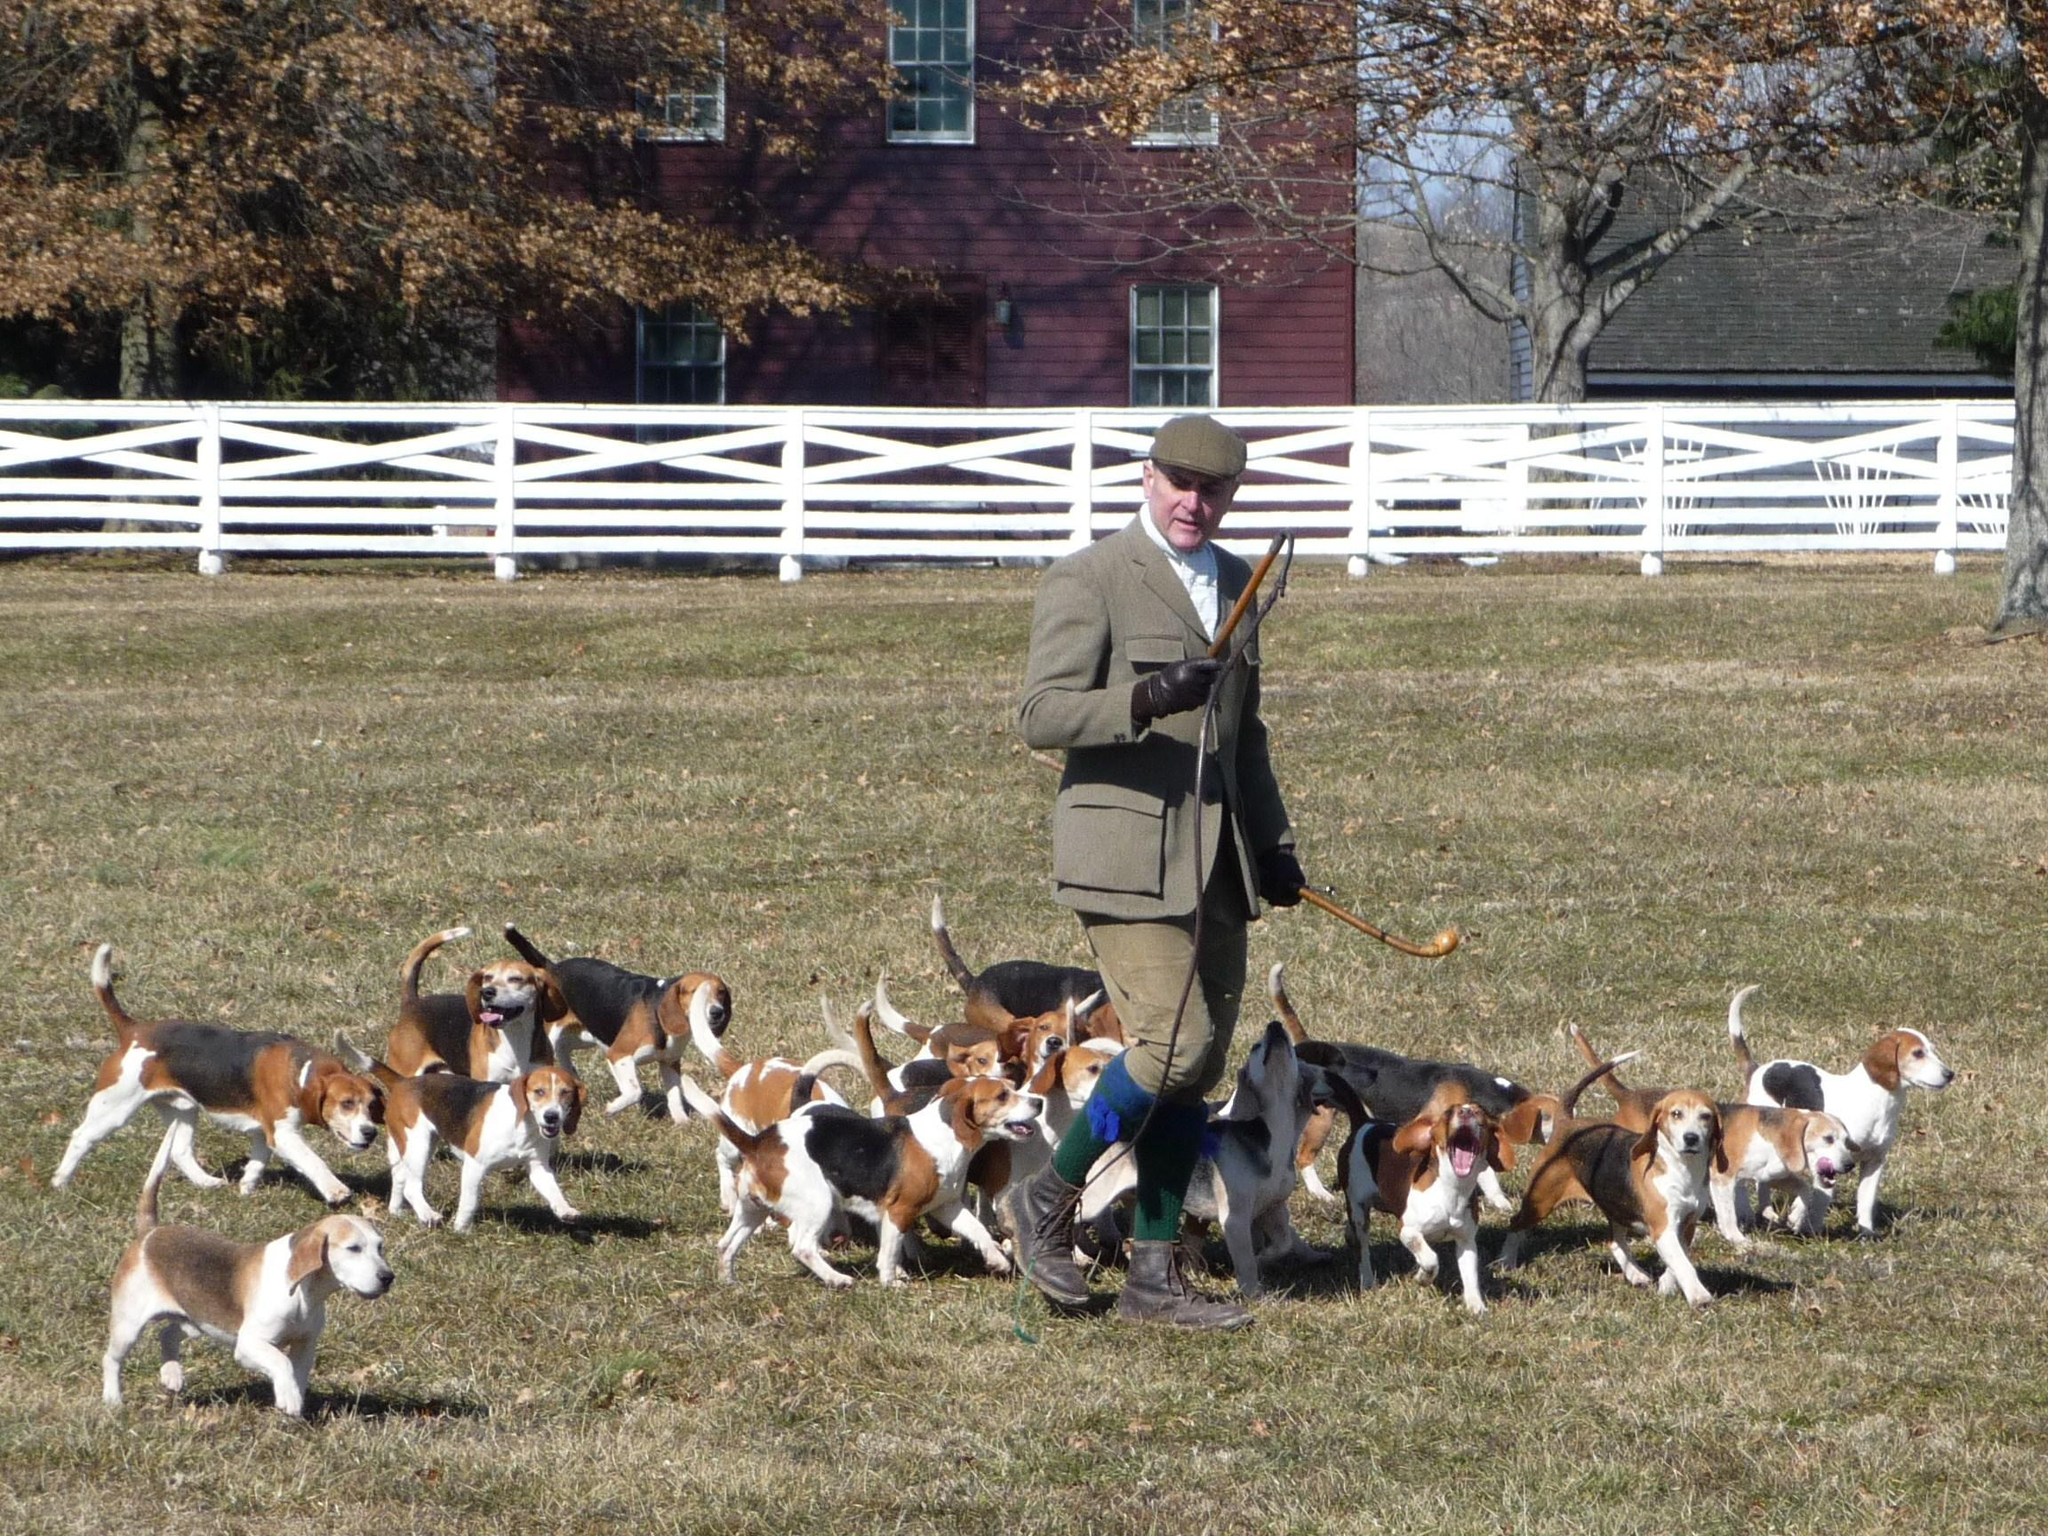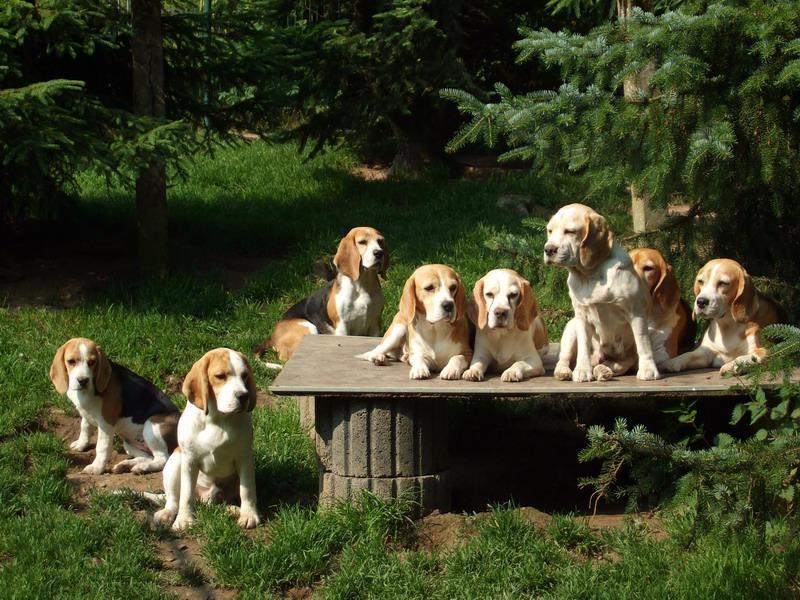The first image is the image on the left, the second image is the image on the right. Evaluate the accuracy of this statement regarding the images: "A man is with a group of dogs in a grassy area in the image on the left.". Is it true? Answer yes or no. Yes. 